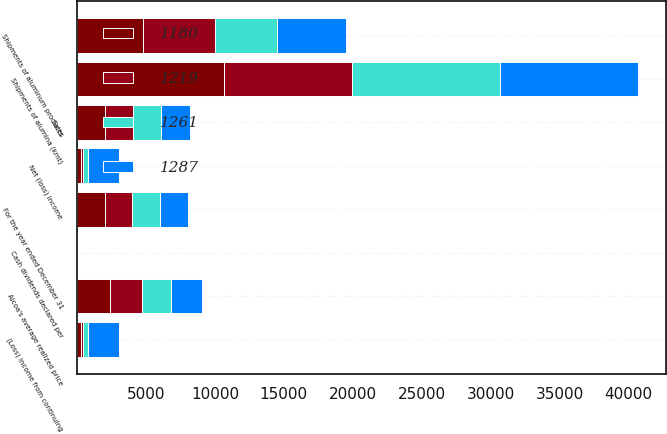Convert chart. <chart><loc_0><loc_0><loc_500><loc_500><stacked_bar_chart><ecel><fcel>For the year ended December 31<fcel>Sales<fcel>(Loss) income from continuing<fcel>Net (loss) income<fcel>Shipments of alumina (kmt)<fcel>Shipments of aluminum products<fcel>Alcoa's average realized price<fcel>Cash dividends declared per<nl><fcel>1261<fcel>2015<fcel>2042<fcel>322<fcel>322<fcel>10755<fcel>4537<fcel>2069<fcel>0.12<nl><fcel>1180<fcel>2014<fcel>2042<fcel>268<fcel>268<fcel>10652<fcel>4794<fcel>2405<fcel>0.12<nl><fcel>1287<fcel>2013<fcel>2042<fcel>2285<fcel>2285<fcel>9966<fcel>4994<fcel>2243<fcel>0.12<nl><fcel>1219<fcel>2012<fcel>2042<fcel>191<fcel>191<fcel>9295<fcel>5197<fcel>2327<fcel>0.12<nl></chart> 